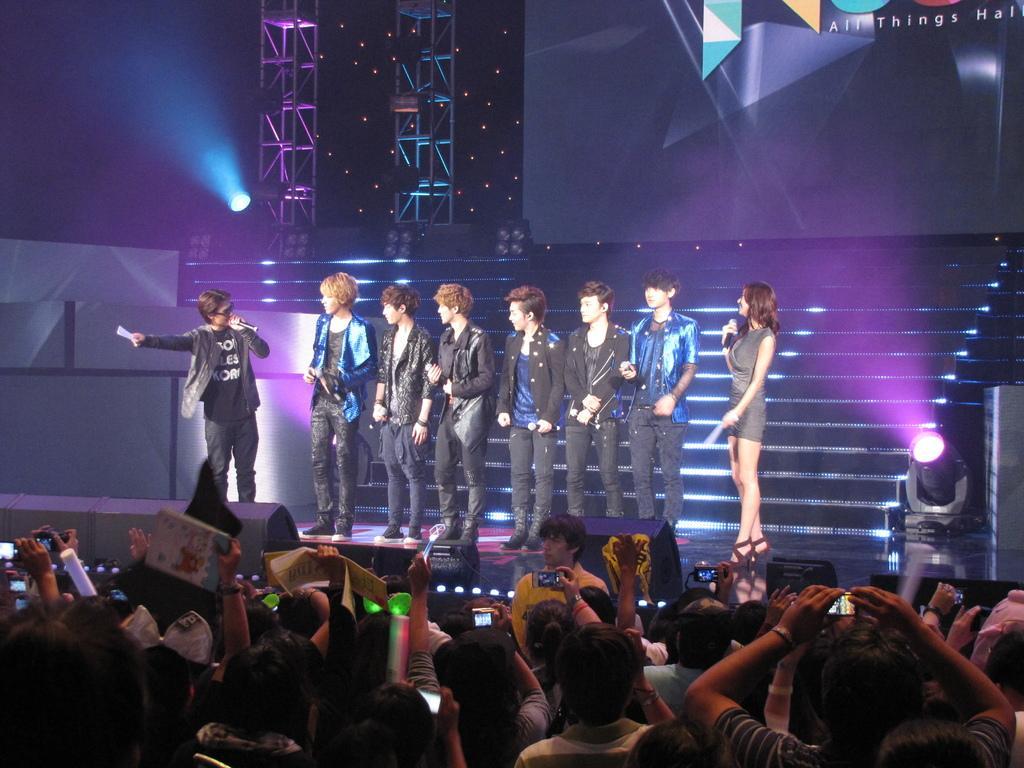How would you summarize this image in a sentence or two? This picture describes about group of people, few people holding cameras and few people holding microphones, in front of them we can see few lights and metal rods, in the top right hand corner we can see some text. 